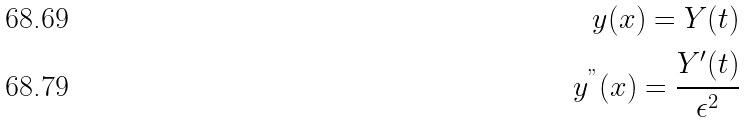<formula> <loc_0><loc_0><loc_500><loc_500>y ( x ) = Y ( t ) \\ y ^ { " } ( x ) = \cfrac { Y ^ { \prime } ( t ) } { \epsilon ^ { 2 } }</formula> 